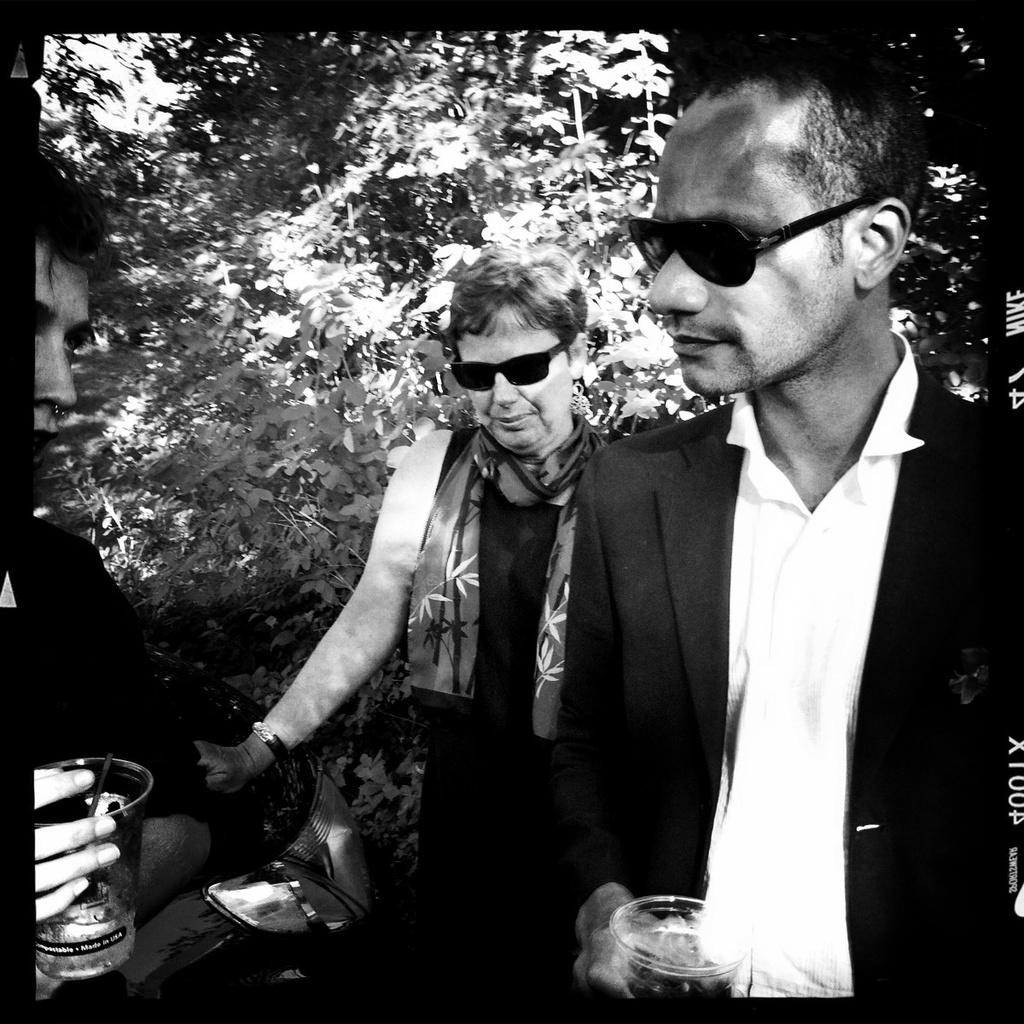How many people are present in the image? There are three people in the image, and there are additional people present as well. Can you describe the appearance of some people in the image? Some people in the image are wearing glasses. What are some people holding in the image? Some people are holding glasses with liquid in them. What can be seen in the background of the image? Plants and trees are visible in the background of the image. What type of marble is visible in the image? There is no marble present in the image. Is there any smoke visible in the image? There is no smoke visible in the image. 